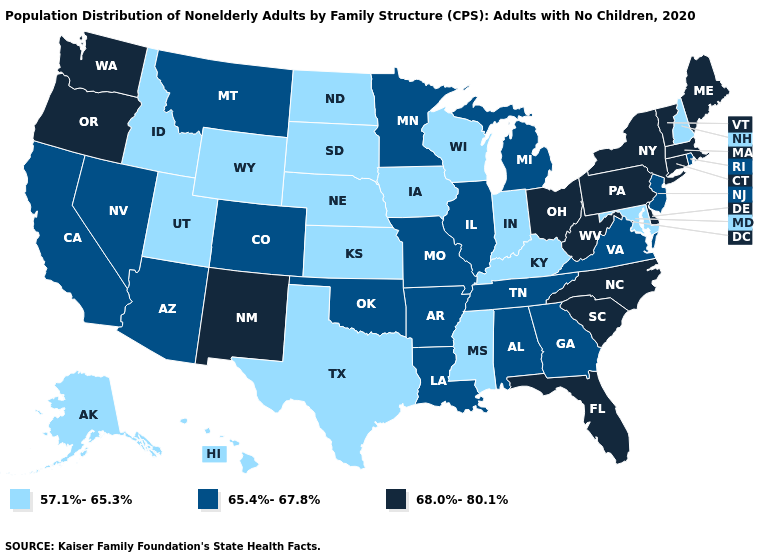What is the value of Colorado?
Quick response, please. 65.4%-67.8%. What is the highest value in states that border Mississippi?
Keep it brief. 65.4%-67.8%. What is the value of South Carolina?
Answer briefly. 68.0%-80.1%. Among the states that border Maryland , does West Virginia have the highest value?
Quick response, please. Yes. What is the highest value in states that border New Jersey?
Short answer required. 68.0%-80.1%. What is the highest value in the USA?
Answer briefly. 68.0%-80.1%. Among the states that border Kentucky , does Indiana have the lowest value?
Keep it brief. Yes. What is the value of Kentucky?
Concise answer only. 57.1%-65.3%. Does Hawaii have the same value as New Jersey?
Write a very short answer. No. What is the value of Minnesota?
Quick response, please. 65.4%-67.8%. Does Wyoming have a lower value than Texas?
Concise answer only. No. What is the lowest value in the South?
Write a very short answer. 57.1%-65.3%. How many symbols are there in the legend?
Write a very short answer. 3. Name the states that have a value in the range 65.4%-67.8%?
Give a very brief answer. Alabama, Arizona, Arkansas, California, Colorado, Georgia, Illinois, Louisiana, Michigan, Minnesota, Missouri, Montana, Nevada, New Jersey, Oklahoma, Rhode Island, Tennessee, Virginia. 